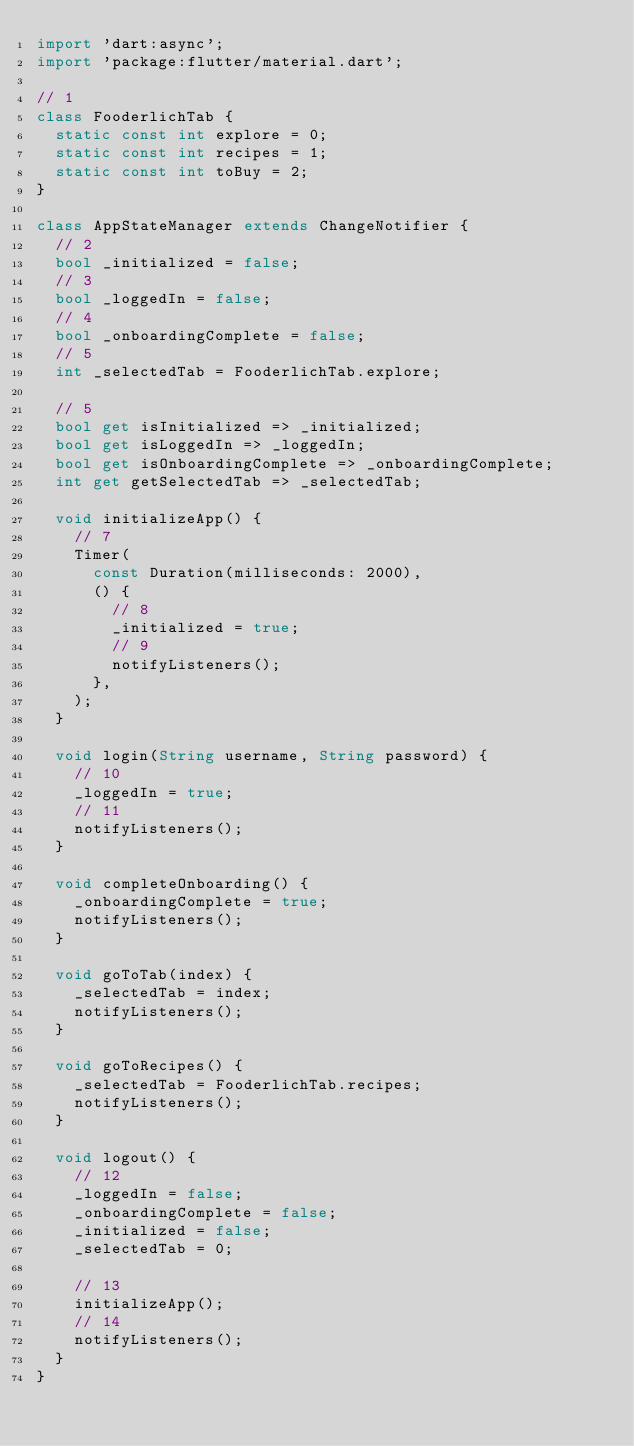Convert code to text. <code><loc_0><loc_0><loc_500><loc_500><_Dart_>import 'dart:async';
import 'package:flutter/material.dart';

// 1
class FooderlichTab {
  static const int explore = 0;
  static const int recipes = 1;
  static const int toBuy = 2;
}

class AppStateManager extends ChangeNotifier {
  // 2
  bool _initialized = false;
  // 3
  bool _loggedIn = false;
  // 4
  bool _onboardingComplete = false;
  // 5
  int _selectedTab = FooderlichTab.explore;

  // 5
  bool get isInitialized => _initialized;
  bool get isLoggedIn => _loggedIn;
  bool get isOnboardingComplete => _onboardingComplete;
  int get getSelectedTab => _selectedTab;

  void initializeApp() {
    // 7
    Timer(
      const Duration(milliseconds: 2000),
      () {
        // 8
        _initialized = true;
        // 9
        notifyListeners();
      },
    );
  }

  void login(String username, String password) {
    // 10
    _loggedIn = true;
    // 11
    notifyListeners();
  }

  void completeOnboarding() {
    _onboardingComplete = true;
    notifyListeners();
  }

  void goToTab(index) {
    _selectedTab = index;
    notifyListeners();
  }

  void goToRecipes() {
    _selectedTab = FooderlichTab.recipes;
    notifyListeners();
  }

  void logout() {
    // 12
    _loggedIn = false;
    _onboardingComplete = false;
    _initialized = false;
    _selectedTab = 0;

    // 13
    initializeApp();
    // 14
    notifyListeners();
  }
}
</code> 